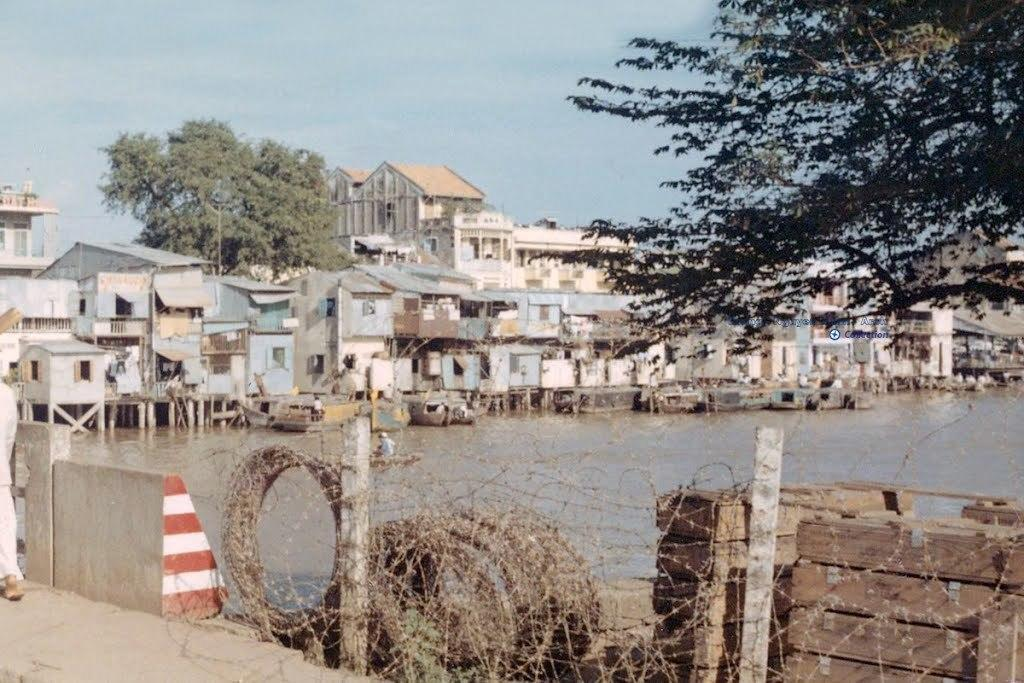What is the primary element visible in the image? There is water in the image. What type of structures can be seen in the image? There are houses in the image. What other natural elements are present in the image? There are trees in the image. What is visible at the top of the image? The sky is visible at the top of the image. What type of produce is being harvested in the image? There is no produce or harvesting activity present in the image. What discovery was made by the person standing near the tramp in the image? There is no tramp or person present in the image. 